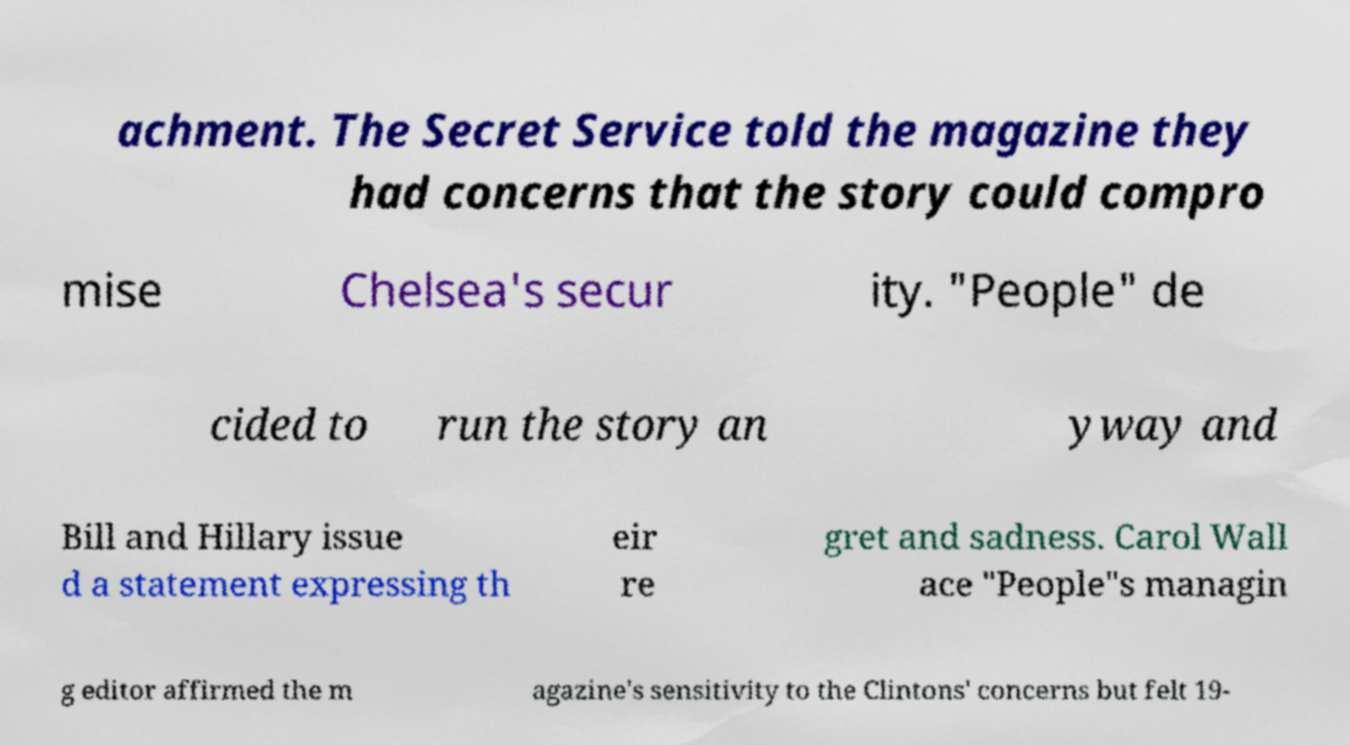I need the written content from this picture converted into text. Can you do that? achment. The Secret Service told the magazine they had concerns that the story could compro mise Chelsea's secur ity. "People" de cided to run the story an yway and Bill and Hillary issue d a statement expressing th eir re gret and sadness. Carol Wall ace "People"s managin g editor affirmed the m agazine's sensitivity to the Clintons' concerns but felt 19- 